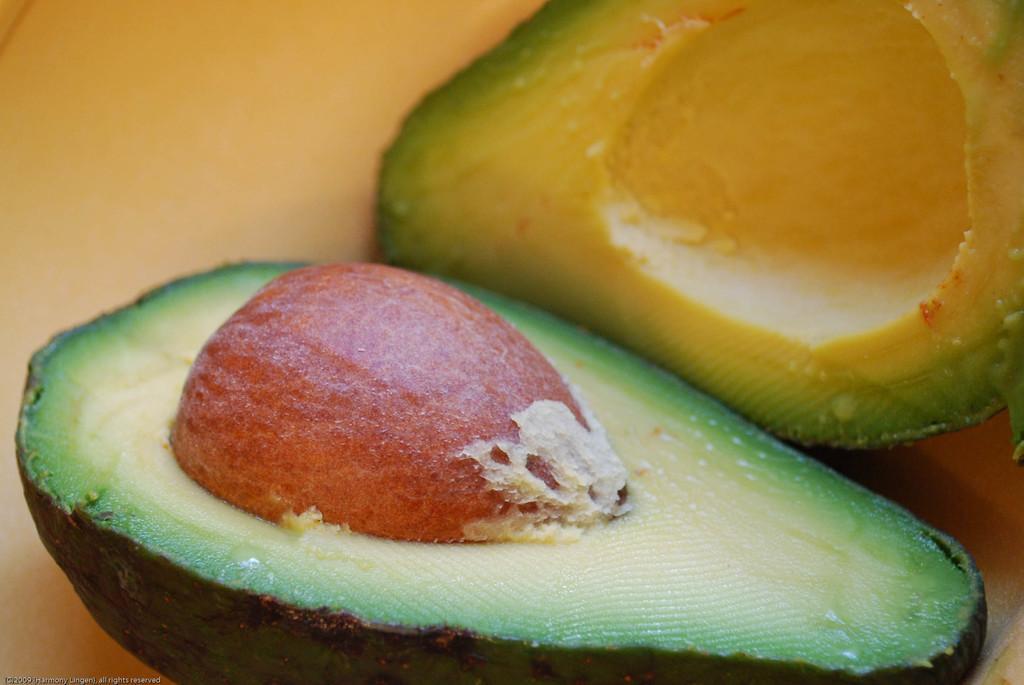Describe this image in one or two sentences. In this image, I can see avocado, which is cut into two pieces. This is the seed in the avocado. 